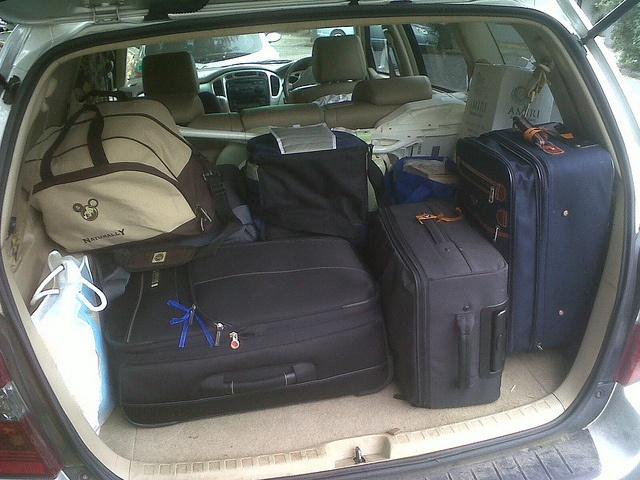Describe the objects in this image and their specific colors. I can see suitcase in black and gray tones, suitcase in black, gray, and darkblue tones, suitcase in black and gray tones, backpack in black, gray, and darkgray tones, and backpack in black, navy, and gray tones in this image. 